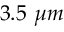Convert formula to latex. <formula><loc_0><loc_0><loc_500><loc_500>3 . 5 \ \mu m</formula> 